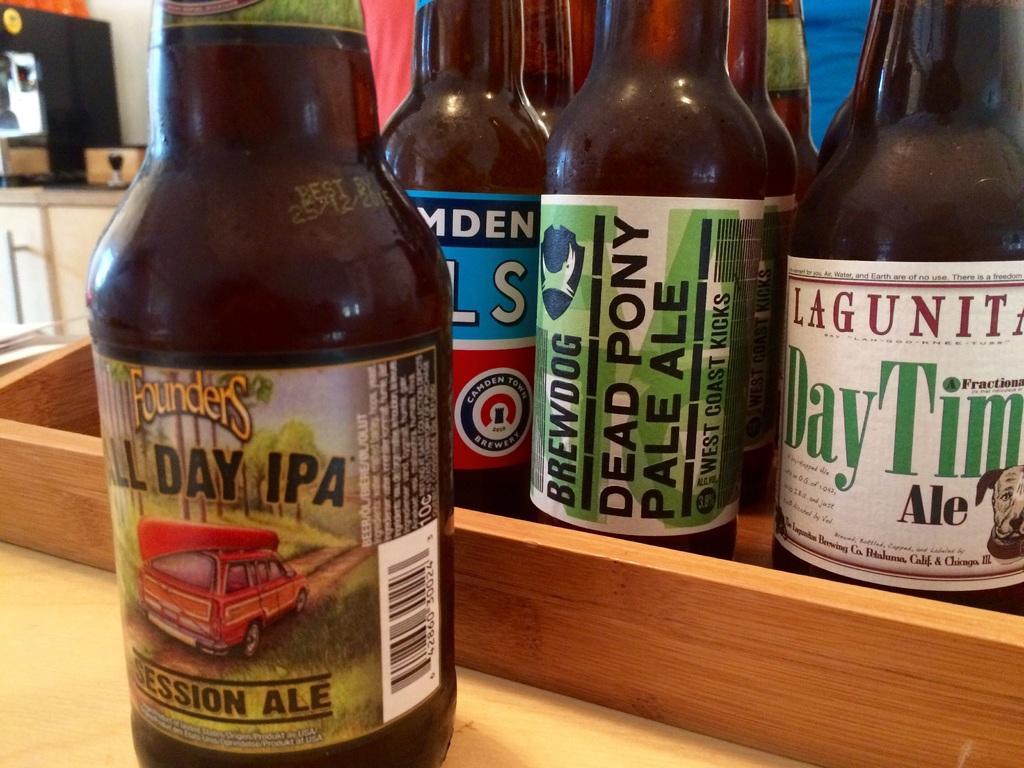<image>
Create a compact narrative representing the image presented. A bottle of Dead Pony Pale Ale next to other bottles of beer 